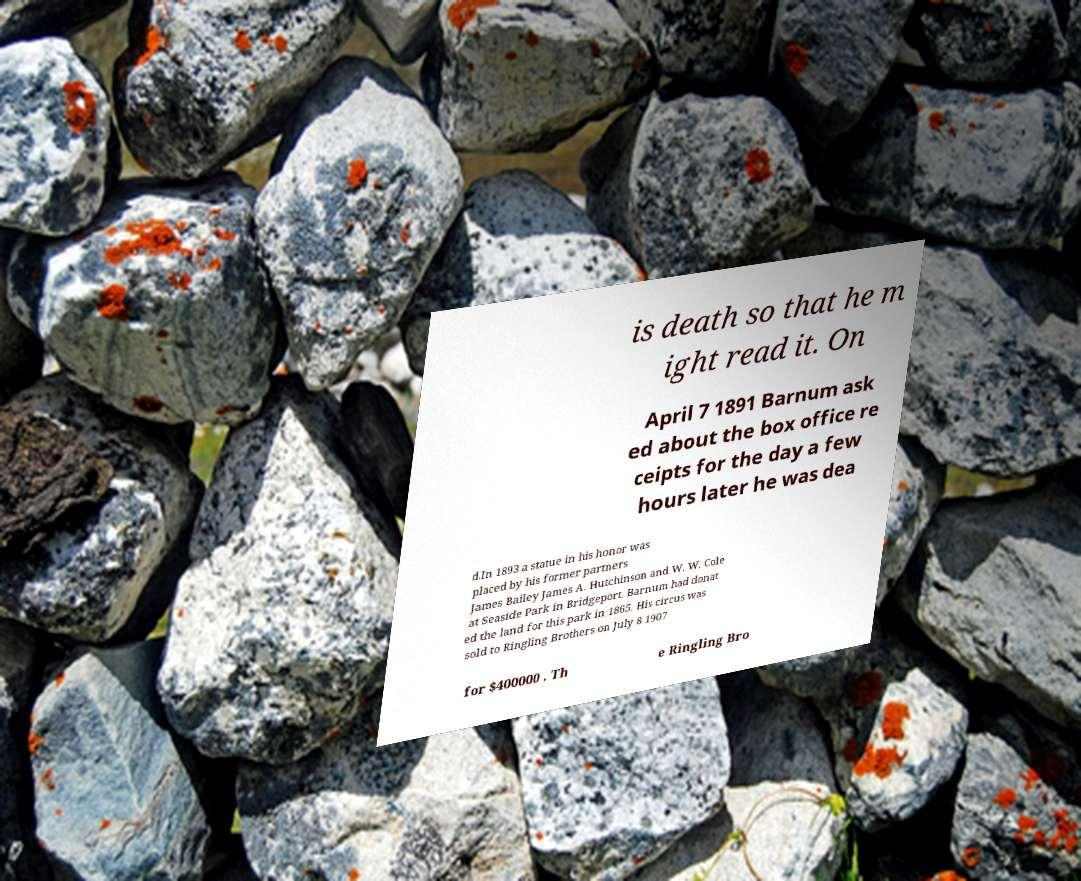Please read and relay the text visible in this image. What does it say? is death so that he m ight read it. On April 7 1891 Barnum ask ed about the box office re ceipts for the day a few hours later he was dea d.In 1893 a statue in his honor was placed by his former partners James Bailey James A. Hutchinson and W. W. Cole at Seaside Park in Bridgeport. Barnum had donat ed the land for this park in 1865. His circus was sold to Ringling Brothers on July 8 1907 for $400000 . Th e Ringling Bro 